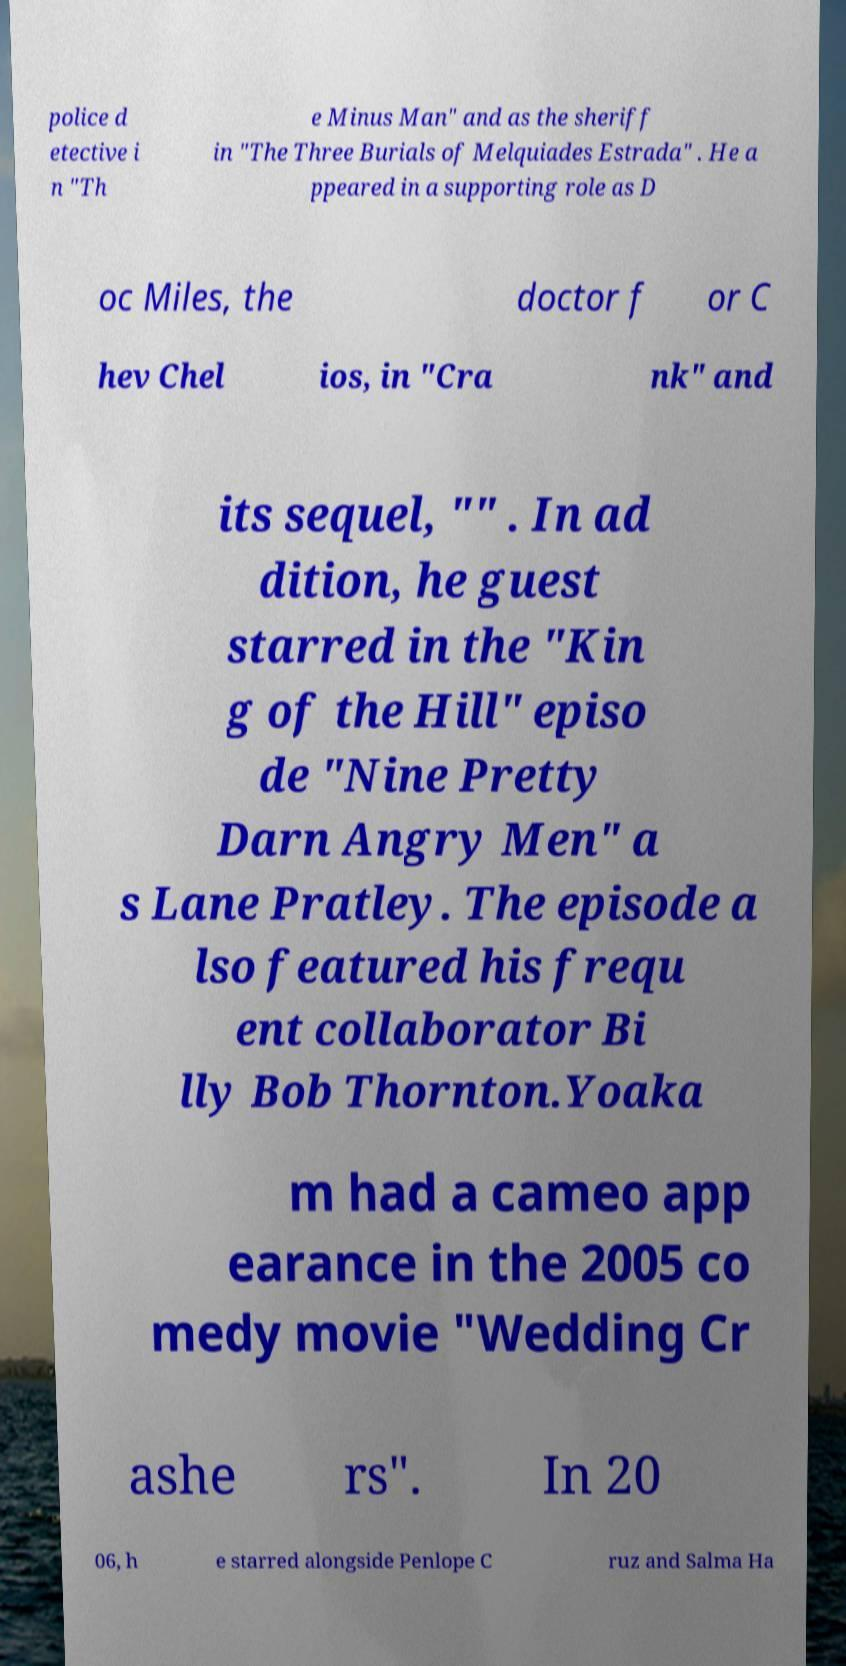Could you assist in decoding the text presented in this image and type it out clearly? police d etective i n "Th e Minus Man" and as the sheriff in "The Three Burials of Melquiades Estrada" . He a ppeared in a supporting role as D oc Miles, the doctor f or C hev Chel ios, in "Cra nk" and its sequel, "" . In ad dition, he guest starred in the "Kin g of the Hill" episo de "Nine Pretty Darn Angry Men" a s Lane Pratley. The episode a lso featured his frequ ent collaborator Bi lly Bob Thornton.Yoaka m had a cameo app earance in the 2005 co medy movie "Wedding Cr ashe rs". In 20 06, h e starred alongside Penlope C ruz and Salma Ha 